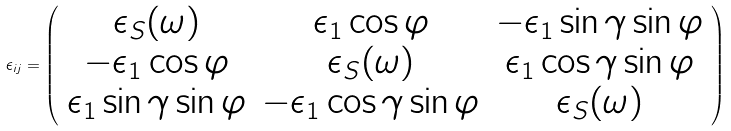<formula> <loc_0><loc_0><loc_500><loc_500>\epsilon _ { i j } = \left ( \begin{array} { c c c } \epsilon _ { S } ( \omega ) & \epsilon _ { 1 } \cos \varphi & - \epsilon _ { 1 } \sin \gamma \sin \varphi \\ - \epsilon _ { 1 } \cos \varphi & \epsilon _ { S } ( \omega ) & \epsilon _ { 1 } \cos \gamma \sin \varphi \\ \epsilon _ { 1 } \sin \gamma \sin \varphi & - \epsilon _ { 1 } \cos \gamma \sin \varphi & \epsilon _ { S } ( \omega ) \end{array} \right )</formula> 